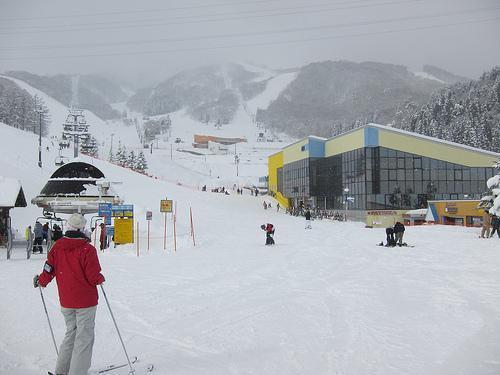How many people with red on?
Give a very brief answer. 2. 